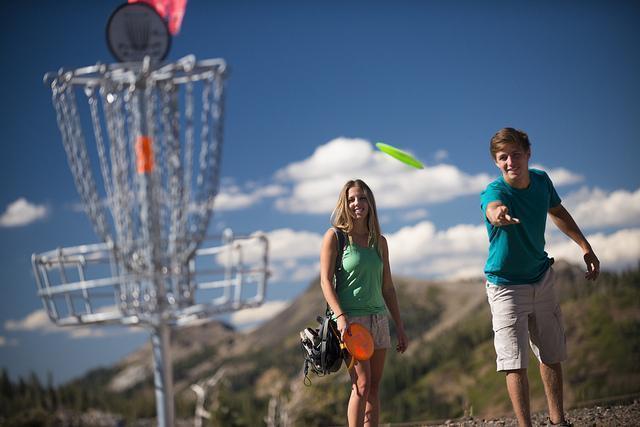How many people can you see?
Give a very brief answer. 2. 